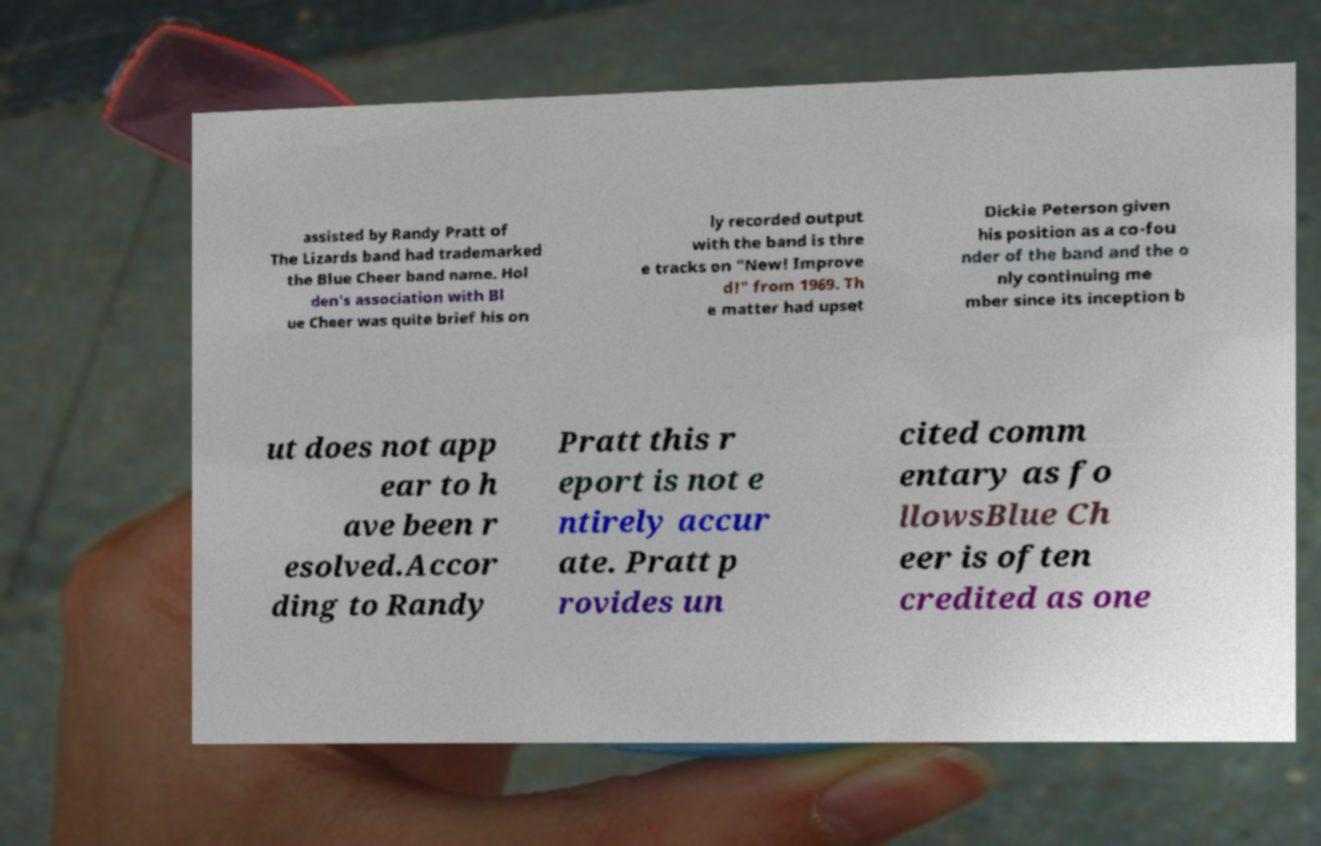Could you extract and type out the text from this image? assisted by Randy Pratt of The Lizards band had trademarked the Blue Cheer band name. Hol den's association with Bl ue Cheer was quite brief his on ly recorded output with the band is thre e tracks on "New! Improve d!" from 1969. Th e matter had upset Dickie Peterson given his position as a co-fou nder of the band and the o nly continuing me mber since its inception b ut does not app ear to h ave been r esolved.Accor ding to Randy Pratt this r eport is not e ntirely accur ate. Pratt p rovides un cited comm entary as fo llowsBlue Ch eer is often credited as one 